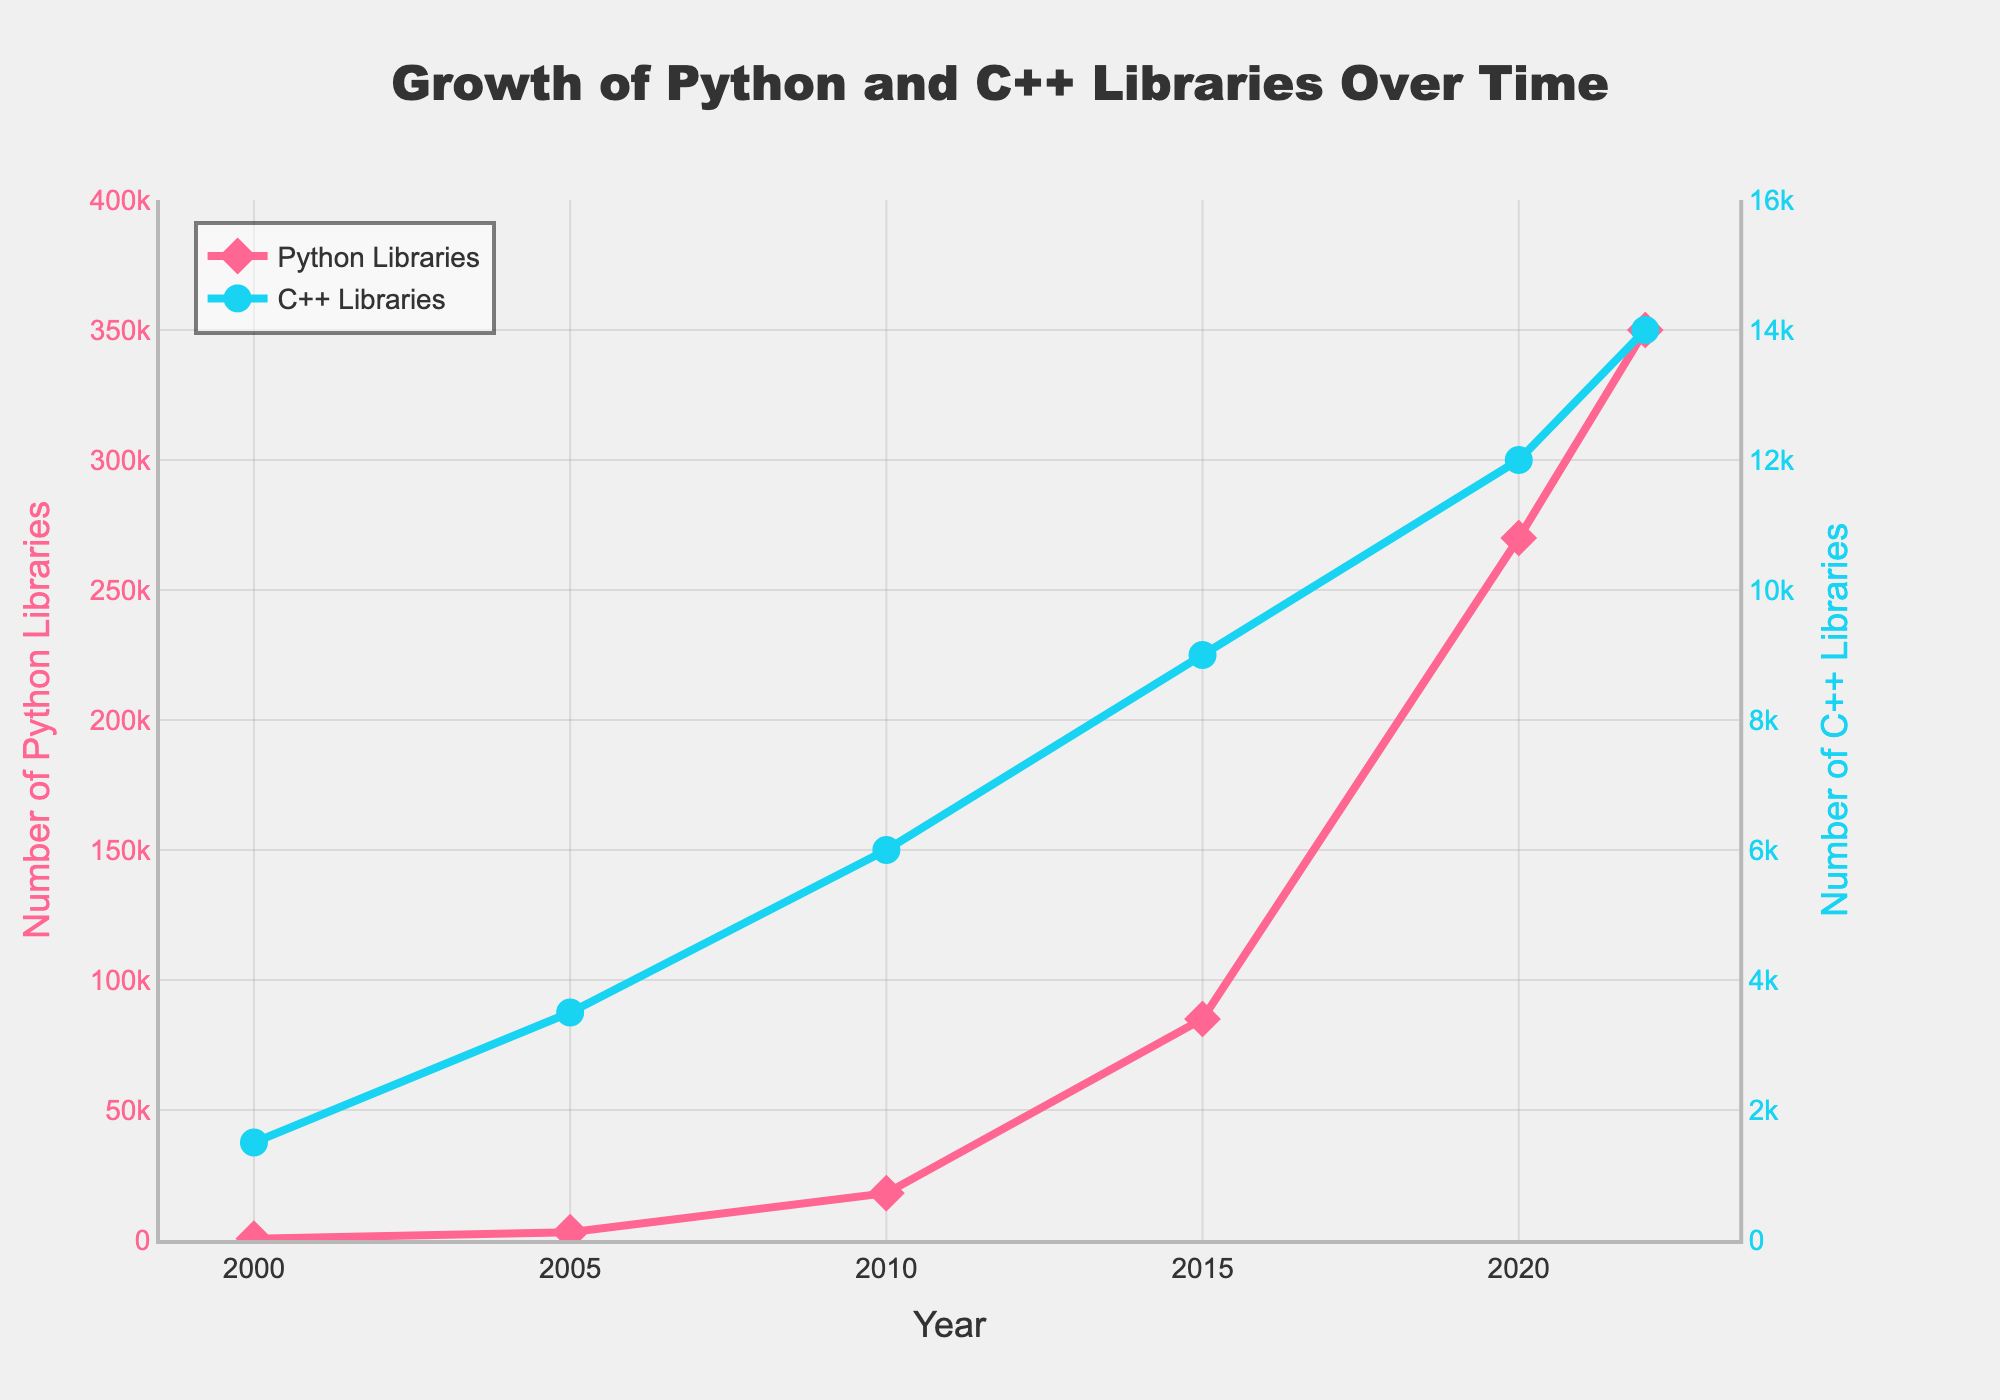What is the total number of Python libraries available in 2020? We look at the y-axis that corresponds to Python libraries and find the data point for the year 2020. The number is 270,000.
Answer: 270,000 How many more Python libraries than C++ libraries were available in 2015? In 2015, the number of Python libraries is 85,000 and the number of C++ libraries is 9,000. The difference is calculated by subtracting the two: 85,000 - 9,000 = 76,000.
Answer: 76,000 In which year did Python libraries surpass C++ libraries? We track the data points of both lines and identify that Python libraries surpassed C++ libraries in 2010.
Answer: 2010 What is the growth in the number of Python libraries from 2000 to 2020? The number of Python libraries in 2000 is 500, and in 2020 it is 270,000. The growth is calculated by subtracting the two numbers: 270,000 - 500 = 269,500.
Answer: 269,500 Which year shows the highest increase in the number of C++ libraries compared to the previous data point? We look at the intervals between each year and calculate the increase. From 2000 to 2005: 3,500 - 1,500 = 2,000, from 2005 to 2010: 6,000 - 3,500 = 2,500, from 2010 to 2015: 9,000 - 6,000 = 3,000, from 2015 to 2020: 12,000 - 9,000 = 3,000, and from 2020 to 2022: 14,000 - 12,000 = 2,000. The highest increase is in 2010 to 2015 and 2015 to 2020, both being 3,000.
Answer: 2015 and 2020 By how many times did the number of Python libraries increase from 2005 to 2022? The number of Python libraries in 2005 is 3,000 and in 2022 it is 350,000. The number of times it increased is calculated by dividing the two numbers: 350,000 / 3,000 ≈ 116.67.
Answer: ≈ 117 Which set of libraries had a more significant increase between 2005 and 2010? From 2005 to 2010, the number of Python libraries increased from 3,000 to 18,000, resulting in an increase of 15,000. The number of C++ libraries increased from 3,500 to 6,000, resulting in an increase of 2,500. Python libraries had a more significant increase.
Answer: Python libraries How does the visual styling (color and markers) help distinguish between Python and C++ libraries in the plot? The plot uses different colors to represent the two sets of libraries: red for Python libraries and blue for C++ libraries. Additionally, Python libraries are marked with diamonds, while C++ libraries are marked with circles. This visual differentiation helps in easily identifying and distinguishing between the two datasets.
Answer: Color and markers What is the average number of C++ libraries available from 2000 to 2022? The counts of C++ libraries available in each year are 1500, 3500, 6000, 9000, 12000, and 14000. Summing these values gives 1500 + 3500 + 6000 + 9000 + 12000 + 14000 = 46,000. Dividing by the number of data points (6) gives 46,000 / 6 ≈ 7,667.
Answer: ≈ 7,667 What trends can be observed in the growth of Python libraries versus C++ libraries over time? The Python libraries show exponential growth, particularly after 2005, while the C++ libraries show a more linear and slower rate of growth. Python libraries dramatically surpass C++ libraries starting in 2010 and significantly widen the gap in subsequent years.
Answer: Python exponential, C++ linear and slower 